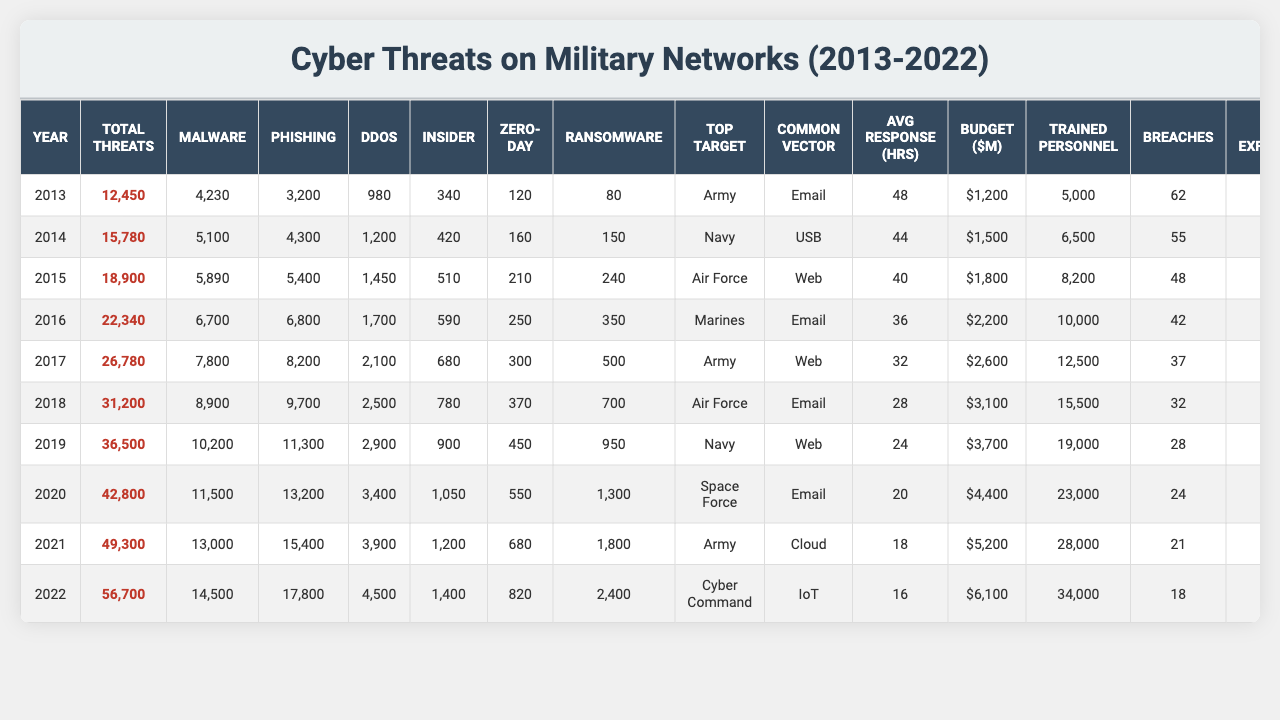What was the total number of detected threats in 2016? In the table, under the "Total Threats" column for the year 2016, the value is 22,340.
Answer: 22,340 Which year saw the highest number of phishing attempts? By looking at the "Phishing Attempts" column, 2022 has the highest value at 17,800.
Answer: 2022 What is the sum of malware incidents and ransomware attacks in 2021? In 2021, malware incidents are 13,000 and ransomware attacks are 1,800. Summing these gives 13,000 + 1,800 = 14,800.
Answer: 14,800 In which year were the least successful breaches reported? The "Successful Breaches" column shows that 2016 reported the least with 42 successful breaches.
Answer: 2016 How many more DDoS attacks were detected in 2022 compared to 2015? For 2022, DDoS attacks are 4,500 and for 2015, they are 1,450. The difference is 4,500 - 1,450 = 3,050.
Answer: 3,050 What is the average number of malware incidents over the decade? The cumulative malware incidents from 2013 to 2022 is 72,780. This is divided by 10 (years) to get an average of 7,278.
Answer: 7,278 What percentage of total detected threats in 2020 were attributed to malware incidents? Total threats in 2020 are 42,800, and malware incidents are 11,500. The percentage is (11,500 / 42,800) * 100, which is approximately 26.85%.
Answer: 26.85% Which military branch was the top targeted branch each year? By reviewing the "Top Targeted Branch" column, it's clear that the branches targeted vary by year, but none is consistently the same throughout. The summary shows a trend: Army (2 times), Navy (2 times), Air Force (2 times), Marines (1 time), Space Force (1 time), and Cyber Command (1 time).
Answer: No consistent target Was there an increase in the training of personnel in cybersecurity from 2013 to 2022? The number of trained personnel increased from 5,000 in 2013 to 34,000 in 2022, showing a clear upward trend (34,000 - 5,000 = 29,000 more trained personnel).
Answer: Yes Which year had the highest number of data exfiltration attempts? From the "Data Exfiltration Attempts" column, the maximum is 3,600 in 2022.
Answer: 2022 